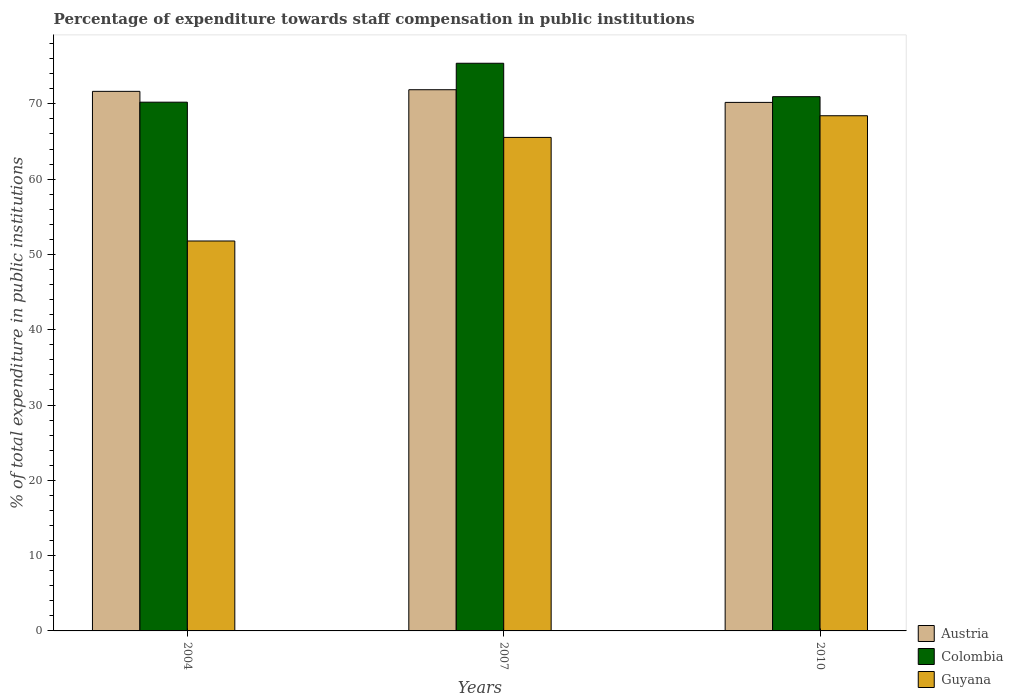How many different coloured bars are there?
Ensure brevity in your answer.  3. Are the number of bars on each tick of the X-axis equal?
Offer a terse response. Yes. How many bars are there on the 2nd tick from the right?
Provide a succinct answer. 3. What is the label of the 2nd group of bars from the left?
Offer a terse response. 2007. What is the percentage of expenditure towards staff compensation in Colombia in 2004?
Your answer should be compact. 70.22. Across all years, what is the maximum percentage of expenditure towards staff compensation in Austria?
Make the answer very short. 71.88. Across all years, what is the minimum percentage of expenditure towards staff compensation in Colombia?
Your response must be concise. 70.22. What is the total percentage of expenditure towards staff compensation in Colombia in the graph?
Make the answer very short. 216.57. What is the difference between the percentage of expenditure towards staff compensation in Austria in 2007 and that in 2010?
Your answer should be very brief. 1.68. What is the difference between the percentage of expenditure towards staff compensation in Colombia in 2007 and the percentage of expenditure towards staff compensation in Guyana in 2010?
Offer a terse response. 6.97. What is the average percentage of expenditure towards staff compensation in Guyana per year?
Your response must be concise. 61.92. In the year 2007, what is the difference between the percentage of expenditure towards staff compensation in Colombia and percentage of expenditure towards staff compensation in Guyana?
Provide a succinct answer. 9.85. In how many years, is the percentage of expenditure towards staff compensation in Colombia greater than 2 %?
Provide a succinct answer. 3. What is the ratio of the percentage of expenditure towards staff compensation in Guyana in 2007 to that in 2010?
Keep it short and to the point. 0.96. Is the percentage of expenditure towards staff compensation in Guyana in 2004 less than that in 2010?
Make the answer very short. Yes. Is the difference between the percentage of expenditure towards staff compensation in Colombia in 2004 and 2007 greater than the difference between the percentage of expenditure towards staff compensation in Guyana in 2004 and 2007?
Your response must be concise. Yes. What is the difference between the highest and the second highest percentage of expenditure towards staff compensation in Guyana?
Offer a terse response. 2.88. What is the difference between the highest and the lowest percentage of expenditure towards staff compensation in Guyana?
Your response must be concise. 16.64. In how many years, is the percentage of expenditure towards staff compensation in Colombia greater than the average percentage of expenditure towards staff compensation in Colombia taken over all years?
Ensure brevity in your answer.  1. What does the 1st bar from the left in 2007 represents?
Provide a succinct answer. Austria. Are all the bars in the graph horizontal?
Give a very brief answer. No. Are the values on the major ticks of Y-axis written in scientific E-notation?
Give a very brief answer. No. Does the graph contain grids?
Your response must be concise. No. How many legend labels are there?
Your answer should be compact. 3. What is the title of the graph?
Provide a succinct answer. Percentage of expenditure towards staff compensation in public institutions. Does "United States" appear as one of the legend labels in the graph?
Your answer should be compact. No. What is the label or title of the Y-axis?
Offer a very short reply. % of total expenditure in public institutions. What is the % of total expenditure in public institutions in Austria in 2004?
Provide a short and direct response. 71.66. What is the % of total expenditure in public institutions of Colombia in 2004?
Provide a short and direct response. 70.22. What is the % of total expenditure in public institutions of Guyana in 2004?
Your response must be concise. 51.79. What is the % of total expenditure in public institutions of Austria in 2007?
Keep it short and to the point. 71.88. What is the % of total expenditure in public institutions of Colombia in 2007?
Give a very brief answer. 75.39. What is the % of total expenditure in public institutions of Guyana in 2007?
Provide a short and direct response. 65.54. What is the % of total expenditure in public institutions of Austria in 2010?
Offer a terse response. 70.19. What is the % of total expenditure in public institutions in Colombia in 2010?
Your answer should be compact. 70.95. What is the % of total expenditure in public institutions in Guyana in 2010?
Ensure brevity in your answer.  68.42. Across all years, what is the maximum % of total expenditure in public institutions of Austria?
Your response must be concise. 71.88. Across all years, what is the maximum % of total expenditure in public institutions of Colombia?
Your answer should be very brief. 75.39. Across all years, what is the maximum % of total expenditure in public institutions of Guyana?
Offer a very short reply. 68.42. Across all years, what is the minimum % of total expenditure in public institutions in Austria?
Offer a very short reply. 70.19. Across all years, what is the minimum % of total expenditure in public institutions in Colombia?
Your answer should be compact. 70.22. Across all years, what is the minimum % of total expenditure in public institutions of Guyana?
Your response must be concise. 51.79. What is the total % of total expenditure in public institutions of Austria in the graph?
Your answer should be very brief. 213.73. What is the total % of total expenditure in public institutions of Colombia in the graph?
Provide a succinct answer. 216.57. What is the total % of total expenditure in public institutions of Guyana in the graph?
Give a very brief answer. 185.75. What is the difference between the % of total expenditure in public institutions in Austria in 2004 and that in 2007?
Keep it short and to the point. -0.22. What is the difference between the % of total expenditure in public institutions in Colombia in 2004 and that in 2007?
Provide a succinct answer. -5.17. What is the difference between the % of total expenditure in public institutions in Guyana in 2004 and that in 2007?
Offer a very short reply. -13.76. What is the difference between the % of total expenditure in public institutions of Austria in 2004 and that in 2010?
Your answer should be very brief. 1.47. What is the difference between the % of total expenditure in public institutions in Colombia in 2004 and that in 2010?
Provide a short and direct response. -0.73. What is the difference between the % of total expenditure in public institutions of Guyana in 2004 and that in 2010?
Provide a succinct answer. -16.64. What is the difference between the % of total expenditure in public institutions in Austria in 2007 and that in 2010?
Ensure brevity in your answer.  1.68. What is the difference between the % of total expenditure in public institutions in Colombia in 2007 and that in 2010?
Provide a short and direct response. 4.44. What is the difference between the % of total expenditure in public institutions of Guyana in 2007 and that in 2010?
Offer a terse response. -2.88. What is the difference between the % of total expenditure in public institutions of Austria in 2004 and the % of total expenditure in public institutions of Colombia in 2007?
Keep it short and to the point. -3.73. What is the difference between the % of total expenditure in public institutions of Austria in 2004 and the % of total expenditure in public institutions of Guyana in 2007?
Ensure brevity in your answer.  6.12. What is the difference between the % of total expenditure in public institutions of Colombia in 2004 and the % of total expenditure in public institutions of Guyana in 2007?
Keep it short and to the point. 4.68. What is the difference between the % of total expenditure in public institutions of Austria in 2004 and the % of total expenditure in public institutions of Colombia in 2010?
Your answer should be compact. 0.71. What is the difference between the % of total expenditure in public institutions of Austria in 2004 and the % of total expenditure in public institutions of Guyana in 2010?
Your answer should be very brief. 3.24. What is the difference between the % of total expenditure in public institutions of Colombia in 2004 and the % of total expenditure in public institutions of Guyana in 2010?
Provide a succinct answer. 1.8. What is the difference between the % of total expenditure in public institutions of Austria in 2007 and the % of total expenditure in public institutions of Colombia in 2010?
Keep it short and to the point. 0.92. What is the difference between the % of total expenditure in public institutions of Austria in 2007 and the % of total expenditure in public institutions of Guyana in 2010?
Provide a succinct answer. 3.46. What is the difference between the % of total expenditure in public institutions in Colombia in 2007 and the % of total expenditure in public institutions in Guyana in 2010?
Provide a succinct answer. 6.97. What is the average % of total expenditure in public institutions of Austria per year?
Give a very brief answer. 71.24. What is the average % of total expenditure in public institutions in Colombia per year?
Ensure brevity in your answer.  72.19. What is the average % of total expenditure in public institutions in Guyana per year?
Offer a terse response. 61.92. In the year 2004, what is the difference between the % of total expenditure in public institutions in Austria and % of total expenditure in public institutions in Colombia?
Provide a succinct answer. 1.44. In the year 2004, what is the difference between the % of total expenditure in public institutions of Austria and % of total expenditure in public institutions of Guyana?
Ensure brevity in your answer.  19.87. In the year 2004, what is the difference between the % of total expenditure in public institutions in Colombia and % of total expenditure in public institutions in Guyana?
Make the answer very short. 18.44. In the year 2007, what is the difference between the % of total expenditure in public institutions of Austria and % of total expenditure in public institutions of Colombia?
Your response must be concise. -3.51. In the year 2007, what is the difference between the % of total expenditure in public institutions of Austria and % of total expenditure in public institutions of Guyana?
Provide a succinct answer. 6.33. In the year 2007, what is the difference between the % of total expenditure in public institutions of Colombia and % of total expenditure in public institutions of Guyana?
Make the answer very short. 9.85. In the year 2010, what is the difference between the % of total expenditure in public institutions of Austria and % of total expenditure in public institutions of Colombia?
Your answer should be very brief. -0.76. In the year 2010, what is the difference between the % of total expenditure in public institutions of Austria and % of total expenditure in public institutions of Guyana?
Make the answer very short. 1.77. In the year 2010, what is the difference between the % of total expenditure in public institutions in Colombia and % of total expenditure in public institutions in Guyana?
Ensure brevity in your answer.  2.53. What is the ratio of the % of total expenditure in public institutions of Austria in 2004 to that in 2007?
Keep it short and to the point. 1. What is the ratio of the % of total expenditure in public institutions of Colombia in 2004 to that in 2007?
Provide a succinct answer. 0.93. What is the ratio of the % of total expenditure in public institutions of Guyana in 2004 to that in 2007?
Offer a terse response. 0.79. What is the ratio of the % of total expenditure in public institutions in Austria in 2004 to that in 2010?
Provide a succinct answer. 1.02. What is the ratio of the % of total expenditure in public institutions of Colombia in 2004 to that in 2010?
Your answer should be very brief. 0.99. What is the ratio of the % of total expenditure in public institutions in Guyana in 2004 to that in 2010?
Ensure brevity in your answer.  0.76. What is the ratio of the % of total expenditure in public institutions in Colombia in 2007 to that in 2010?
Give a very brief answer. 1.06. What is the ratio of the % of total expenditure in public institutions of Guyana in 2007 to that in 2010?
Make the answer very short. 0.96. What is the difference between the highest and the second highest % of total expenditure in public institutions of Austria?
Offer a very short reply. 0.22. What is the difference between the highest and the second highest % of total expenditure in public institutions in Colombia?
Ensure brevity in your answer.  4.44. What is the difference between the highest and the second highest % of total expenditure in public institutions in Guyana?
Your response must be concise. 2.88. What is the difference between the highest and the lowest % of total expenditure in public institutions in Austria?
Provide a succinct answer. 1.68. What is the difference between the highest and the lowest % of total expenditure in public institutions of Colombia?
Your response must be concise. 5.17. What is the difference between the highest and the lowest % of total expenditure in public institutions of Guyana?
Make the answer very short. 16.64. 